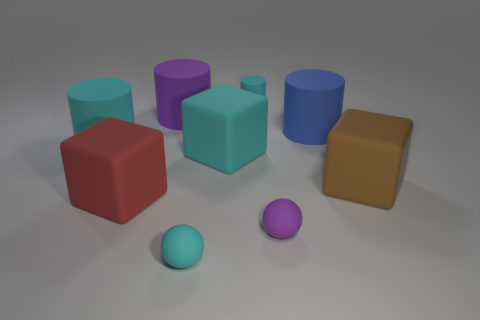What size is the rubber sphere that is the same color as the small cylinder?
Your answer should be very brief. Small. How many large matte things are right of the red matte thing?
Keep it short and to the point. 4. Are there fewer rubber balls to the right of the large brown rubber thing than small brown spheres?
Your answer should be compact. No. There is a small object that is in front of the tiny purple matte ball; what is its color?
Provide a succinct answer. Cyan. What is the shape of the blue rubber object?
Give a very brief answer. Cylinder. Are there any cyan things to the right of the small cyan matte thing that is behind the small purple ball in front of the large red matte thing?
Your answer should be very brief. No. There is a tiny object behind the large cyan rubber object that is on the left side of the cyan thing in front of the red block; what color is it?
Offer a terse response. Cyan. There is a purple rubber object that is behind the cyan rubber cylinder to the left of the purple rubber cylinder; what is its size?
Give a very brief answer. Large. There is a purple thing that is in front of the big brown rubber thing; what is it made of?
Provide a short and direct response. Rubber. The purple ball that is made of the same material as the red cube is what size?
Your answer should be very brief. Small. 